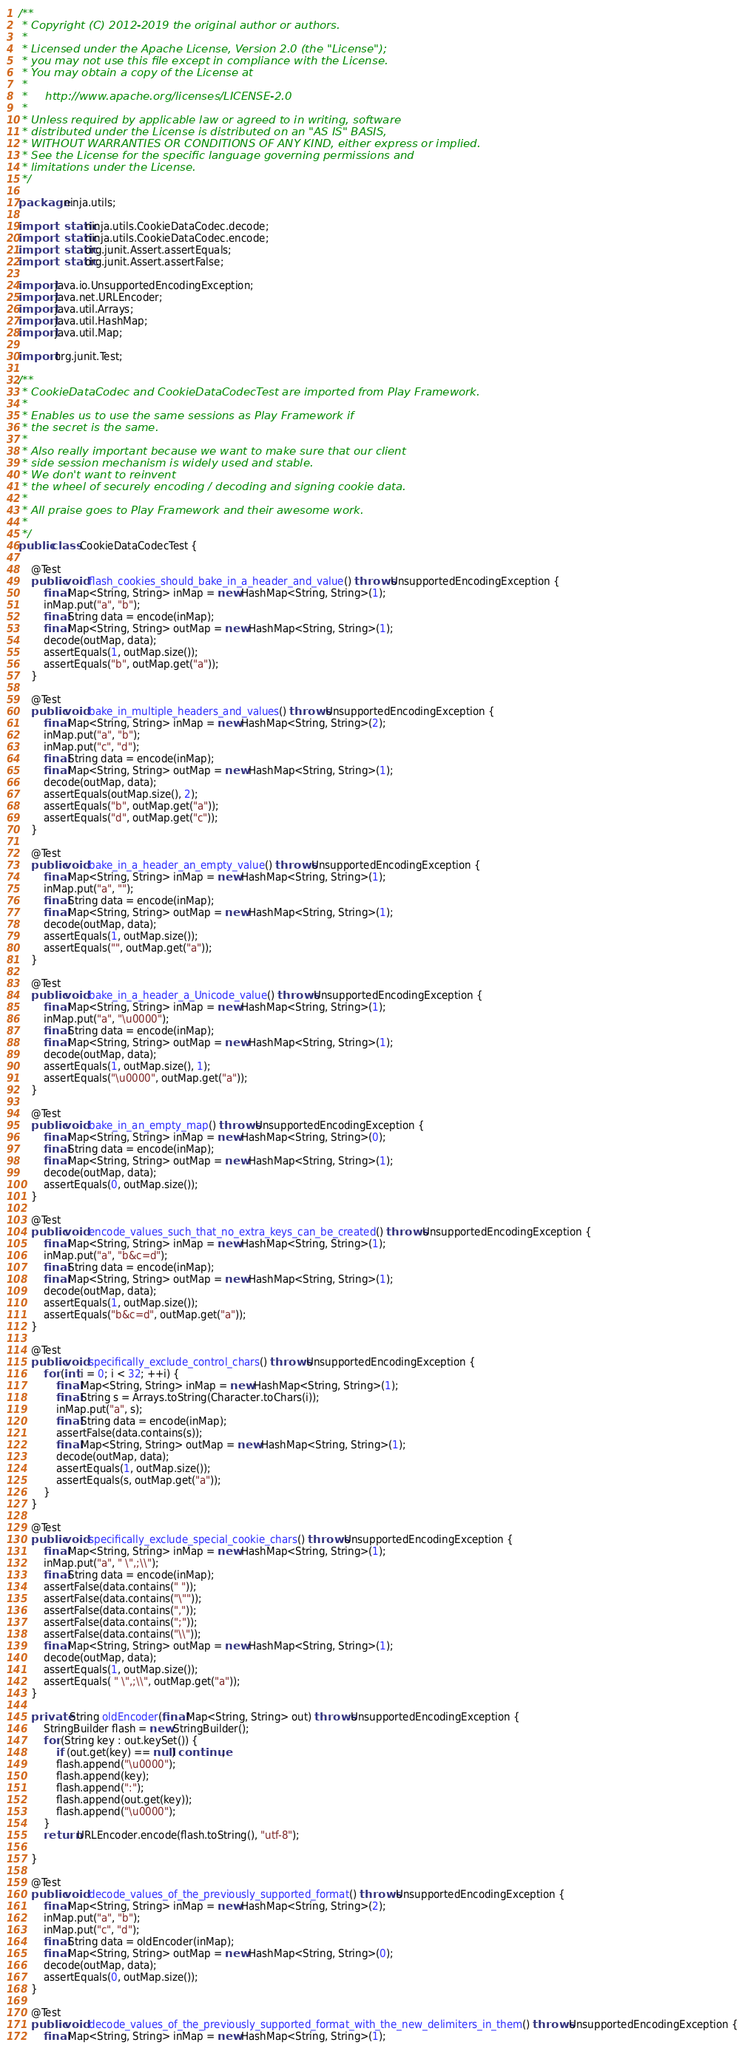Convert code to text. <code><loc_0><loc_0><loc_500><loc_500><_Java_>/**
 * Copyright (C) 2012-2019 the original author or authors.
 *
 * Licensed under the Apache License, Version 2.0 (the "License");
 * you may not use this file except in compliance with the License.
 * You may obtain a copy of the License at
 *
 *     http://www.apache.org/licenses/LICENSE-2.0
 *
 * Unless required by applicable law or agreed to in writing, software
 * distributed under the License is distributed on an "AS IS" BASIS,
 * WITHOUT WARRANTIES OR CONDITIONS OF ANY KIND, either express or implied.
 * See the License for the specific language governing permissions and
 * limitations under the License.
 */

package ninja.utils;

import static ninja.utils.CookieDataCodec.decode;
import static ninja.utils.CookieDataCodec.encode;
import static org.junit.Assert.assertEquals;
import static org.junit.Assert.assertFalse;

import java.io.UnsupportedEncodingException;
import java.net.URLEncoder;
import java.util.Arrays;
import java.util.HashMap;
import java.util.Map;

import org.junit.Test;

/**
 * CookieDataCodec and CookieDataCodecTest are imported from Play Framework.
 * 
 * Enables us to use the same sessions as Play Framework if
 * the secret is the same.
 * 
 * Also really important because we want to make sure that our client
 * side session mechanism is widely used and stable.
 * We don't want to reinvent 
 * the wheel of securely encoding / decoding and signing cookie data.
 * 
 * All praise goes to Play Framework and their awesome work.
 * 
 */
public class CookieDataCodecTest {

    @Test
    public void flash_cookies_should_bake_in_a_header_and_value() throws UnsupportedEncodingException {
        final Map<String, String> inMap = new HashMap<String, String>(1);
        inMap.put("a", "b");
        final String data = encode(inMap);
        final Map<String, String> outMap = new HashMap<String, String>(1);
        decode(outMap, data);
        assertEquals(1, outMap.size());
        assertEquals("b", outMap.get("a"));
    }

    @Test
    public void bake_in_multiple_headers_and_values() throws UnsupportedEncodingException {
        final Map<String, String> inMap = new HashMap<String, String>(2);
        inMap.put("a", "b");
        inMap.put("c", "d");
        final String data = encode(inMap);
        final Map<String, String> outMap = new HashMap<String, String>(1);
        decode(outMap, data);
        assertEquals(outMap.size(), 2);
        assertEquals("b", outMap.get("a"));
        assertEquals("d", outMap.get("c"));
    }

    @Test
    public void bake_in_a_header_an_empty_value() throws UnsupportedEncodingException {
        final Map<String, String> inMap = new HashMap<String, String>(1);
        inMap.put("a", "");
        final String data = encode(inMap);
        final Map<String, String> outMap = new HashMap<String, String>(1);
        decode(outMap, data);
        assertEquals(1, outMap.size());
        assertEquals("", outMap.get("a"));
    }

    @Test
    public void bake_in_a_header_a_Unicode_value() throws UnsupportedEncodingException {
        final Map<String, String> inMap = new HashMap<String, String>(1);
        inMap.put("a", "\u0000");
        final String data = encode(inMap);
        final Map<String, String> outMap = new HashMap<String, String>(1);
        decode(outMap, data);
        assertEquals(1, outMap.size(), 1);
        assertEquals("\u0000", outMap.get("a"));
    }

    @Test
    public void bake_in_an_empty_map() throws UnsupportedEncodingException {
        final Map<String, String> inMap = new HashMap<String, String>(0);
        final String data = encode(inMap);
        final Map<String, String> outMap = new HashMap<String, String>(1);
        decode(outMap, data);
        assertEquals(0, outMap.size());
    }

    @Test
    public void encode_values_such_that_no_extra_keys_can_be_created() throws UnsupportedEncodingException {
        final Map<String, String> inMap = new HashMap<String, String>(1);
        inMap.put("a", "b&c=d");
        final String data = encode(inMap);
        final Map<String, String> outMap = new HashMap<String, String>(1);
        decode(outMap, data);
        assertEquals(1, outMap.size());
        assertEquals("b&c=d", outMap.get("a"));
    }

    @Test
    public void specifically_exclude_control_chars() throws UnsupportedEncodingException {
        for (int i = 0; i < 32; ++i) {
            final Map<String, String> inMap = new HashMap<String, String>(1);
            final String s = Arrays.toString(Character.toChars(i));
            inMap.put("a", s);
            final String data = encode(inMap);
            assertFalse(data.contains(s));
            final Map<String, String> outMap = new HashMap<String, String>(1);
            decode(outMap, data);
            assertEquals(1, outMap.size());
            assertEquals(s, outMap.get("a"));
        }
    }

    @Test
    public void specifically_exclude_special_cookie_chars() throws UnsupportedEncodingException {
        final Map<String, String> inMap = new HashMap<String, String>(1);
        inMap.put("a", " \",;\\");
        final String data = encode(inMap);
        assertFalse(data.contains(" "));
        assertFalse(data.contains("\""));
        assertFalse(data.contains(","));
        assertFalse(data.contains(";"));
        assertFalse(data.contains("\\"));
        final Map<String, String> outMap = new HashMap<String, String>(1);
        decode(outMap, data);
        assertEquals(1, outMap.size());
        assertEquals( " \",;\\", outMap.get("a"));
    }

    private String oldEncoder(final Map<String, String> out) throws UnsupportedEncodingException {
        StringBuilder flash = new StringBuilder();
        for (String key : out.keySet()) {
            if (out.get(key) == null) continue;
            flash.append("\u0000");
            flash.append(key);
            flash.append(":");
            flash.append(out.get(key));
            flash.append("\u0000");
        }
        return URLEncoder.encode(flash.toString(), "utf-8");

    }

    @Test
    public void decode_values_of_the_previously_supported_format() throws UnsupportedEncodingException {
        final Map<String, String> inMap = new HashMap<String, String>(2);
        inMap.put("a", "b");
        inMap.put("c", "d");
        final String data = oldEncoder(inMap);
        final Map<String, String> outMap = new HashMap<String, String>(0);
        decode(outMap, data);
        assertEquals(0, outMap.size());
    }

    @Test
    public void decode_values_of_the_previously_supported_format_with_the_new_delimiters_in_them() throws UnsupportedEncodingException {
        final Map<String, String> inMap = new HashMap<String, String>(1);</code> 